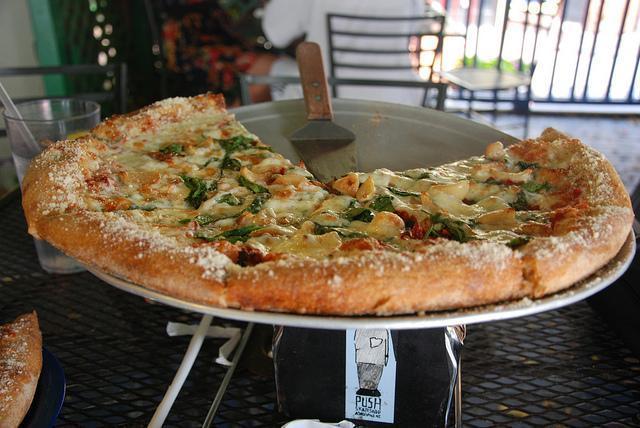What ingredients are on the pizza?
Indicate the correct response and explain using: 'Answer: answer
Rationale: rationale.'
Options: Spinach, pepperoni, pineapple, bacon. Answer: spinach.
Rationale: There is some spinach on top of the pizza. 